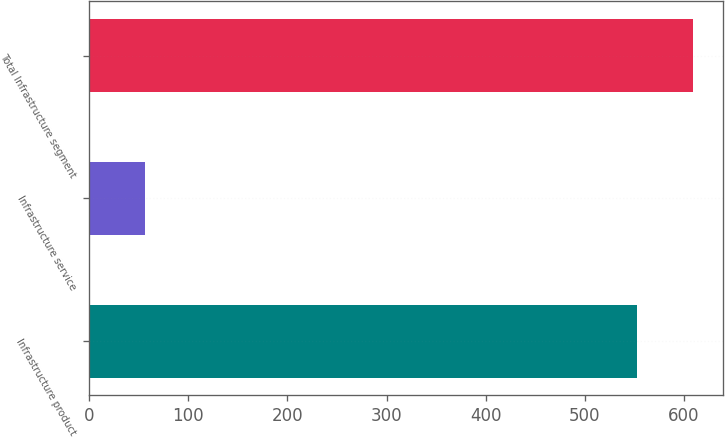<chart> <loc_0><loc_0><loc_500><loc_500><bar_chart><fcel>Infrastructure product<fcel>Infrastructure service<fcel>Total Infrastructure segment<nl><fcel>552.4<fcel>56.3<fcel>608.7<nl></chart> 